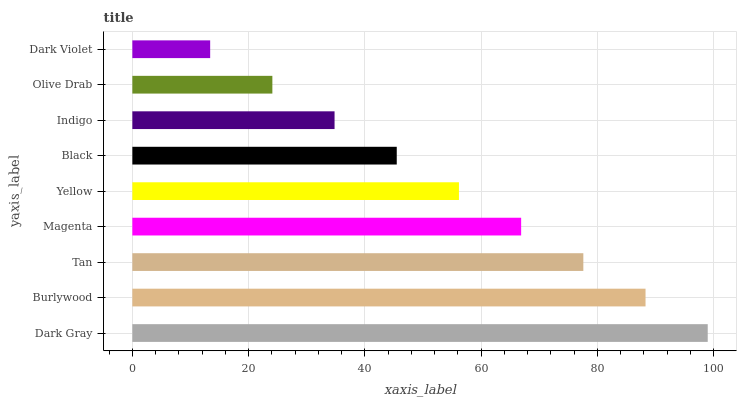Is Dark Violet the minimum?
Answer yes or no. Yes. Is Dark Gray the maximum?
Answer yes or no. Yes. Is Burlywood the minimum?
Answer yes or no. No. Is Burlywood the maximum?
Answer yes or no. No. Is Dark Gray greater than Burlywood?
Answer yes or no. Yes. Is Burlywood less than Dark Gray?
Answer yes or no. Yes. Is Burlywood greater than Dark Gray?
Answer yes or no. No. Is Dark Gray less than Burlywood?
Answer yes or no. No. Is Yellow the high median?
Answer yes or no. Yes. Is Yellow the low median?
Answer yes or no. Yes. Is Black the high median?
Answer yes or no. No. Is Dark Violet the low median?
Answer yes or no. No. 